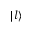<formula> <loc_0><loc_0><loc_500><loc_500>| l \rangle</formula> 